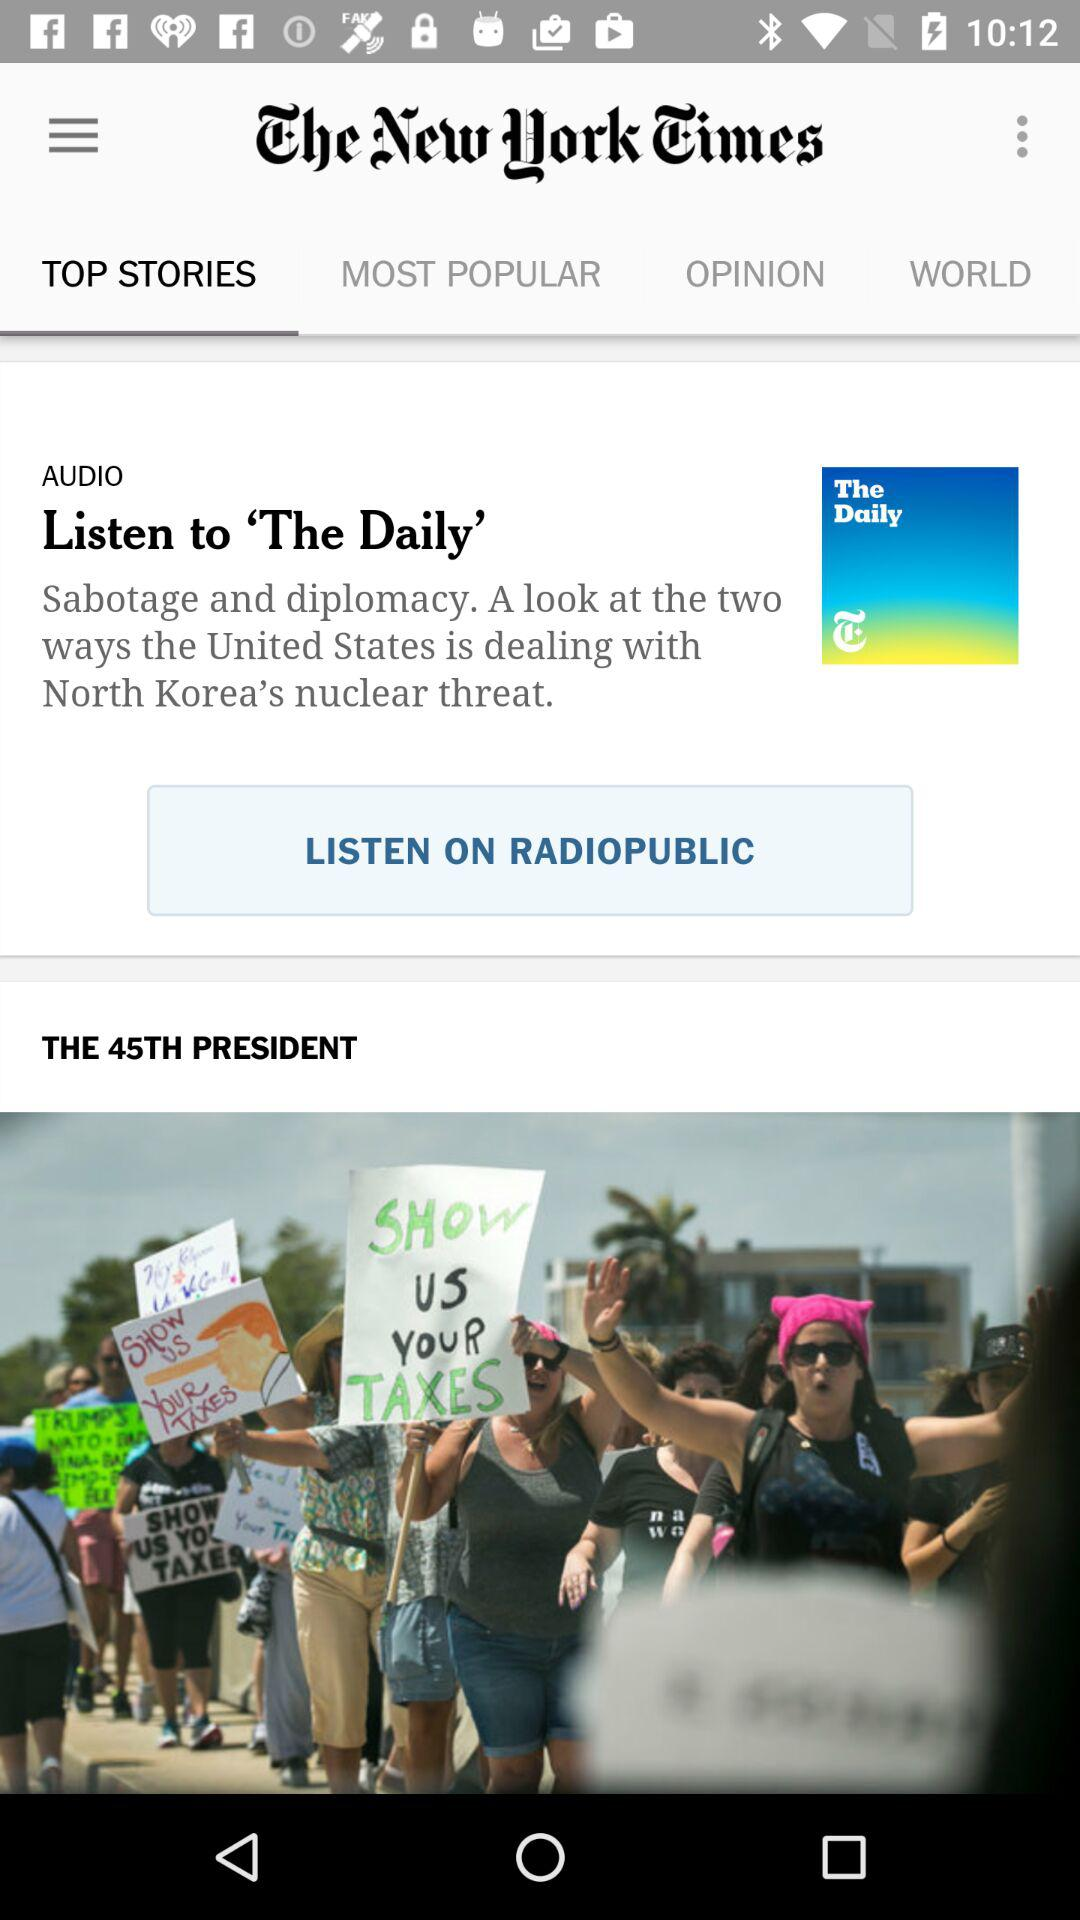What is the application name? The application name is "The New York Times". 